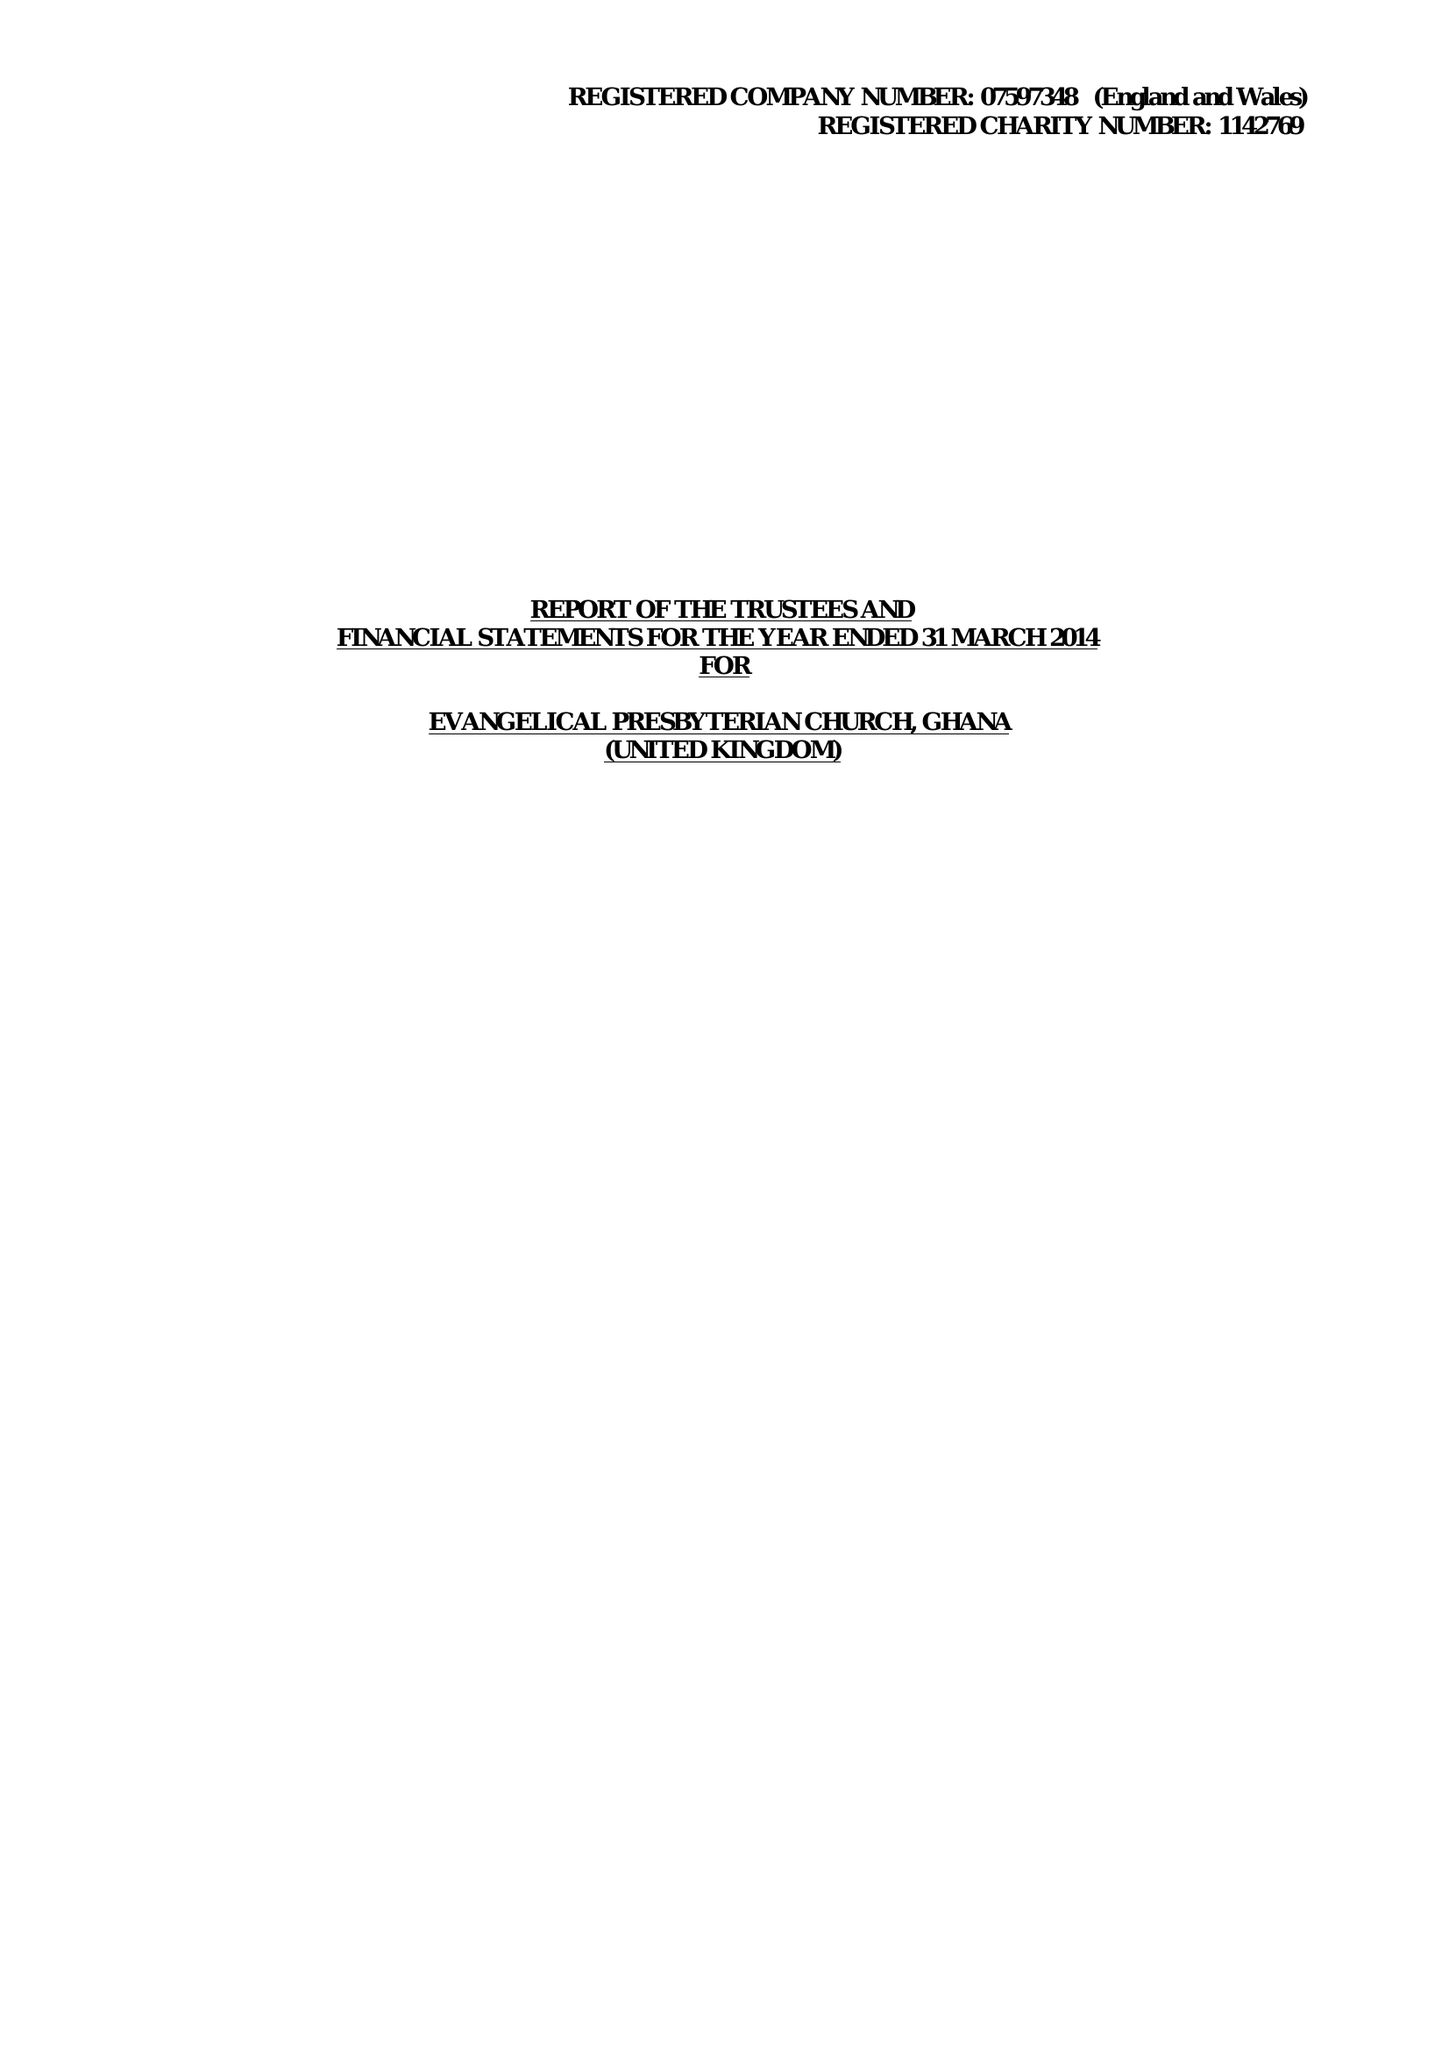What is the value for the charity_number?
Answer the question using a single word or phrase. 1142769 